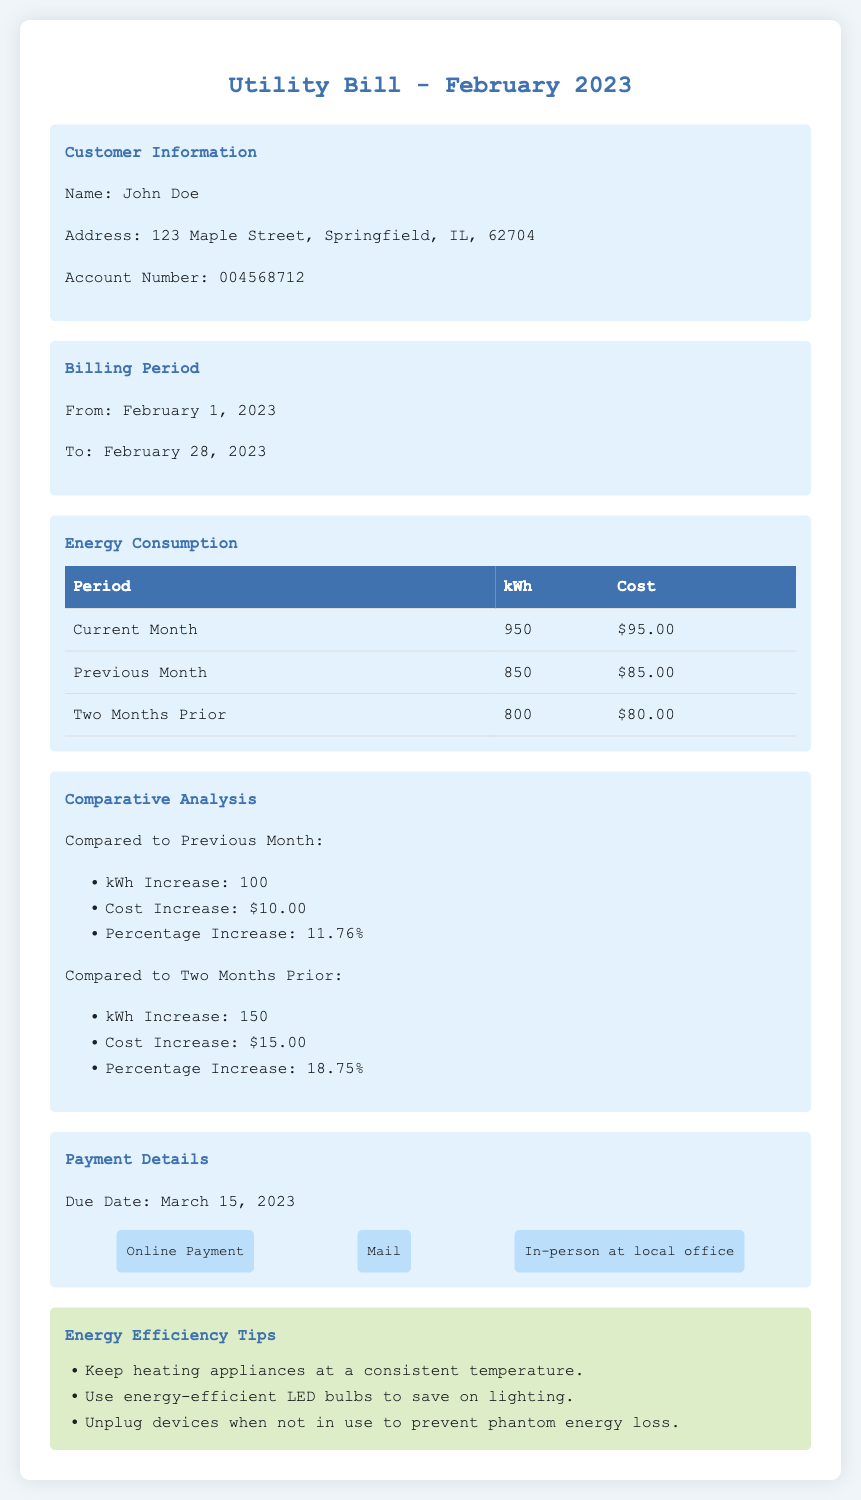What is the billing period? The billing period is specified in the document as starting on February 1, 2023, and ending on February 28, 2023.
Answer: February 1, 2023 - February 28, 2023 How much energy was consumed in the current month? The document states the energy consumption for the current month as 950 kWh.
Answer: 950 kWh What was the cost for the previous month? The cost for the previous month is listed in the document as $85.00.
Answer: $85.00 What is the percentage increase in cost compared to the previous month? The percentage increase in cost is calculated from the comparative analysis section, which states an increase of 11.76%.
Answer: 11.76% What is the due date for the payment? The due date for the payment is provided in the payment details section as March 15, 2023.
Answer: March 15, 2023 How much did the energy consumption increase compared to two months prior? The document indicates an increase of 150 kWh compared to two months prior.
Answer: 150 kWh What is one energy efficiency tip mentioned in the document? The document provides several tips; one of them is about keeping heating appliances at a consistent temperature.
Answer: Keep heating appliances at a consistent temperature 